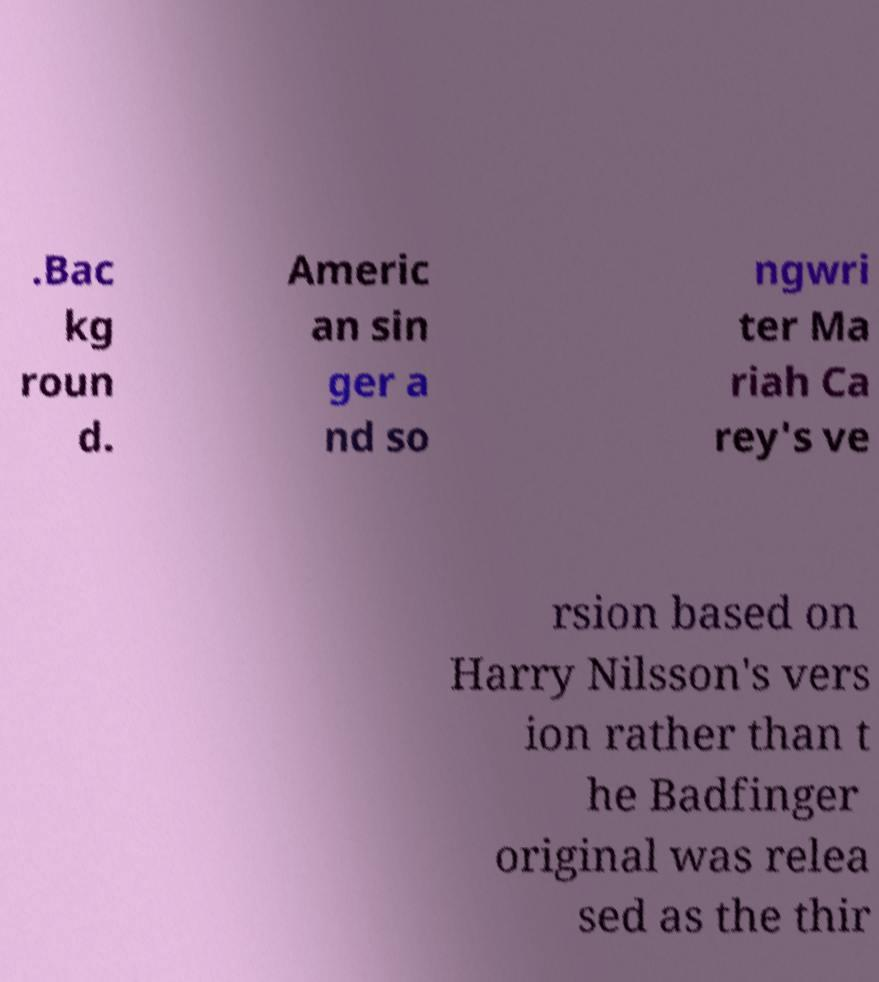For documentation purposes, I need the text within this image transcribed. Could you provide that? .Bac kg roun d. Americ an sin ger a nd so ngwri ter Ma riah Ca rey's ve rsion based on Harry Nilsson's vers ion rather than t he Badfinger original was relea sed as the thir 